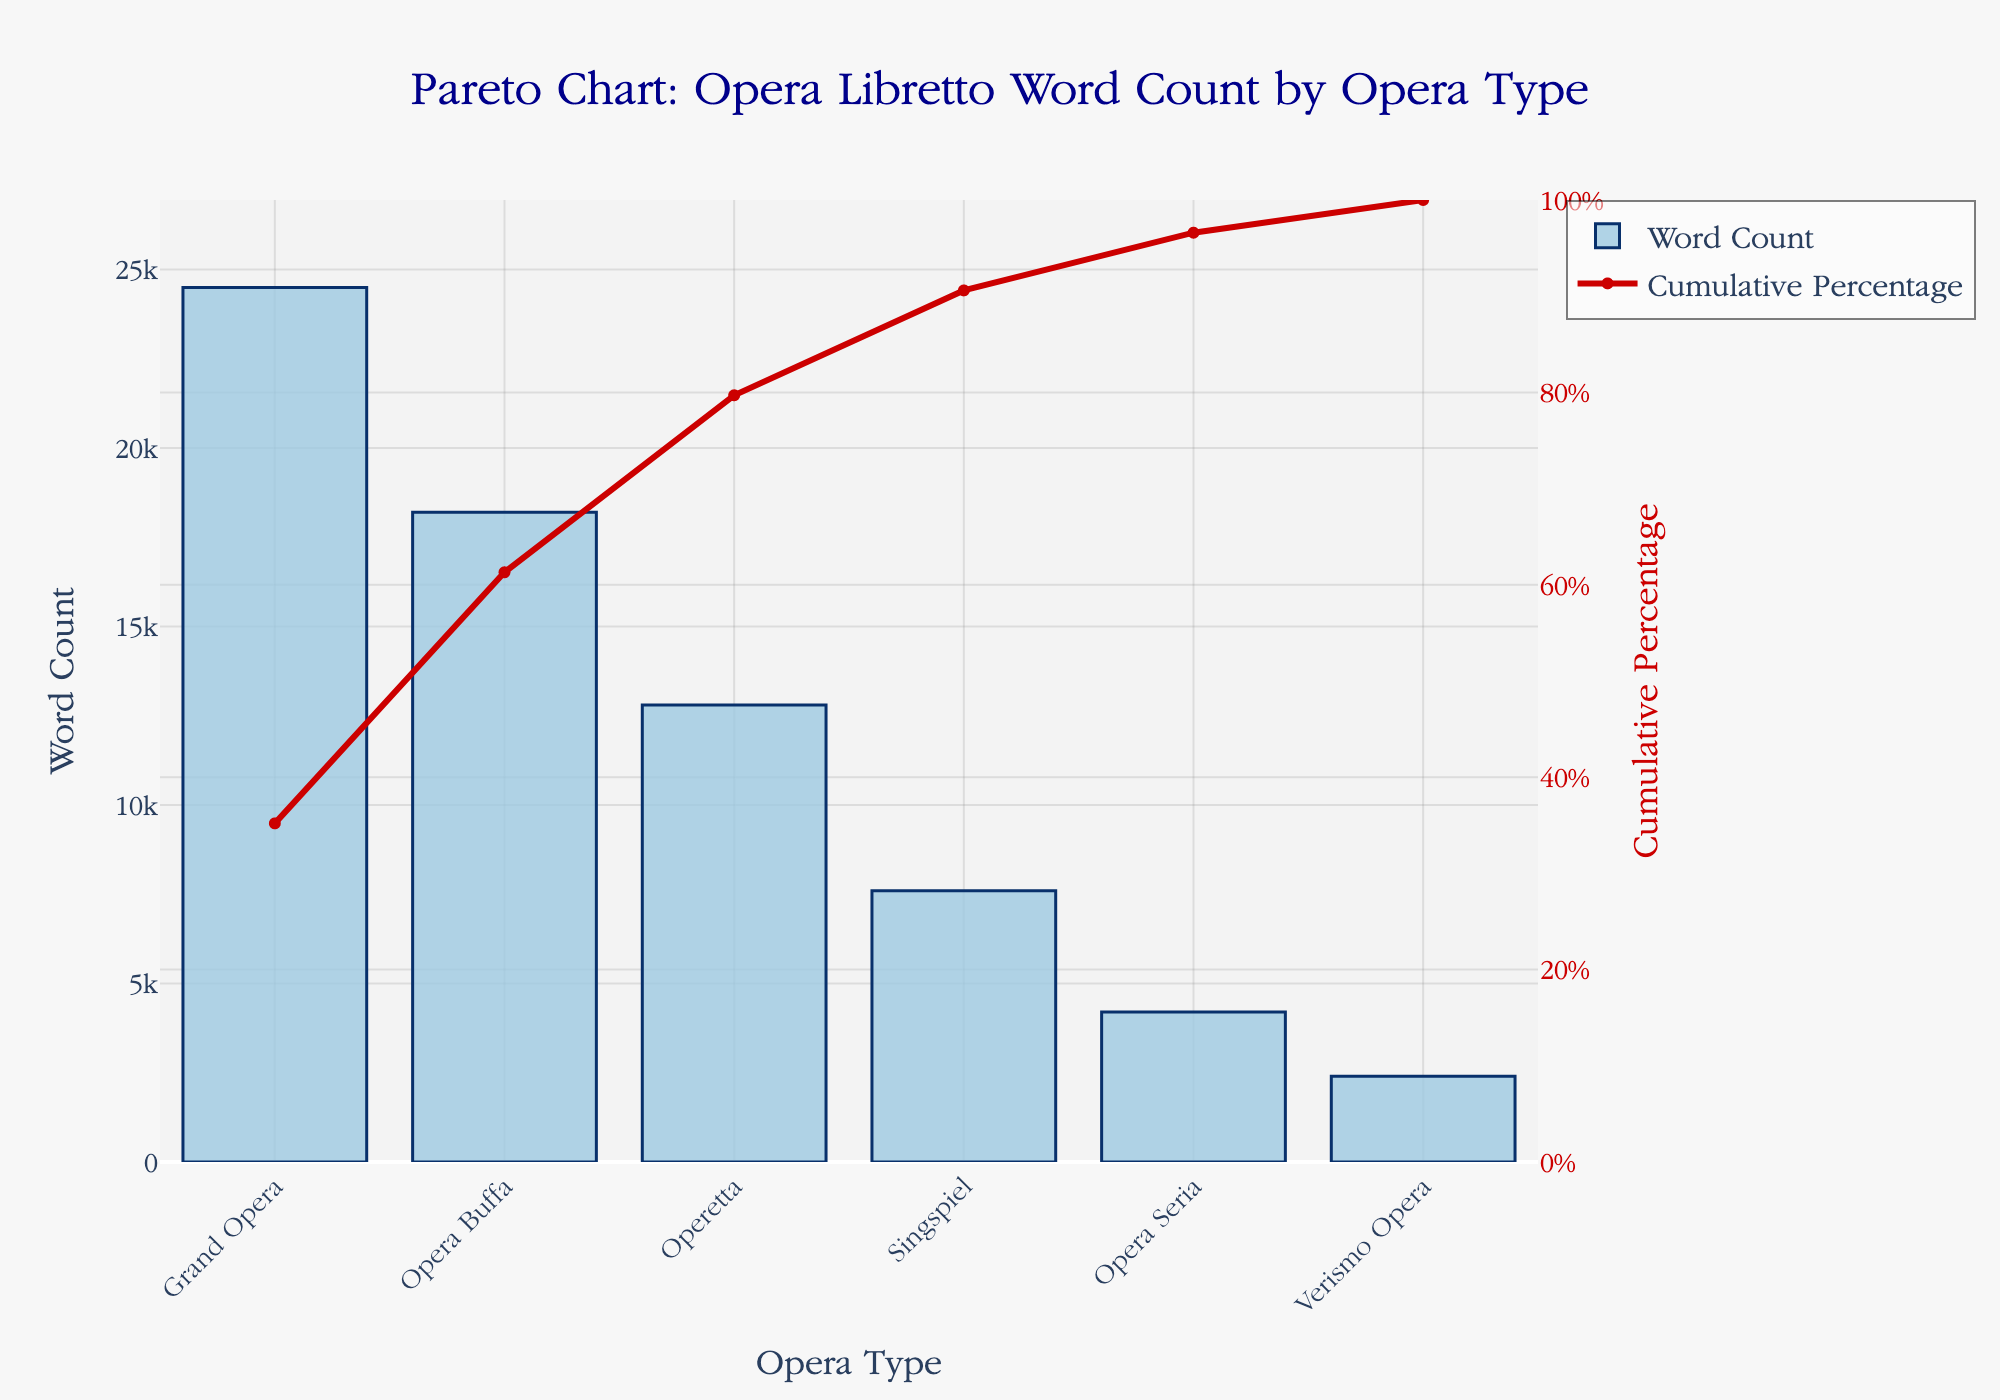What is the title of the chart? The title is typically located at the top of the chart, and it is labeled explicitly. By looking at the chart, the title can be read directly.
Answer: Pareto Chart: Opera Libretto Word Count by Opera Type Which opera type has the highest word count? The bar with the highest value on the primary y-axis (Word Count) represents the opera type with the highest word count.
Answer: Grand Opera What is the cumulative percentage of the top two opera types? The cumulative percentage line chart shows the sum of percentages up to each category. By adding the percentages of Grand Opera and Opera Buffa, you get the cumulative percentage.
Answer: 61.3% Which opera type contributes to the 50% word count threshold? Look at where the cumulative percentage line crosses the 50% mark on the secondary y-axis and identify the corresponding opera type on the x-axis.
Answer: Opera Buffa How many opera types have a word count greater than 10,000? Identify the bars in the chart with heights exceeding 10,000 on the primary y-axis.
Answer: Three (Grand Opera, Opera Buffa, Operetta) What is the word count difference between Grand Opera and Opera Buffa? Subtract the word count of Opera Buffa from the word count of Grand Opera.
Answer: 6,300 What percentage of word counts does the least represented opera type contribute? Check the percentage value given for Verismo Opera, which is the least represented.
Answer: 3.4% What word count does Operetta have, and how does it compare to Singspiel? Locate the word count value for both Operetta and Singspiel, then compare them.
Answer: Operetta has 12,800 words, Singspiel has 7,600 words What is the cumulative percentage after Operetta? Find the cumulative percentage value after including Operetta from the line chart data.
Answer: 79.7% When looking at the word counts of the top three opera types, what is their total combined word count? Add the word counts of Grand Opera, Opera Buffa, and Operetta to find the total combined word count.
Answer: 55,500 